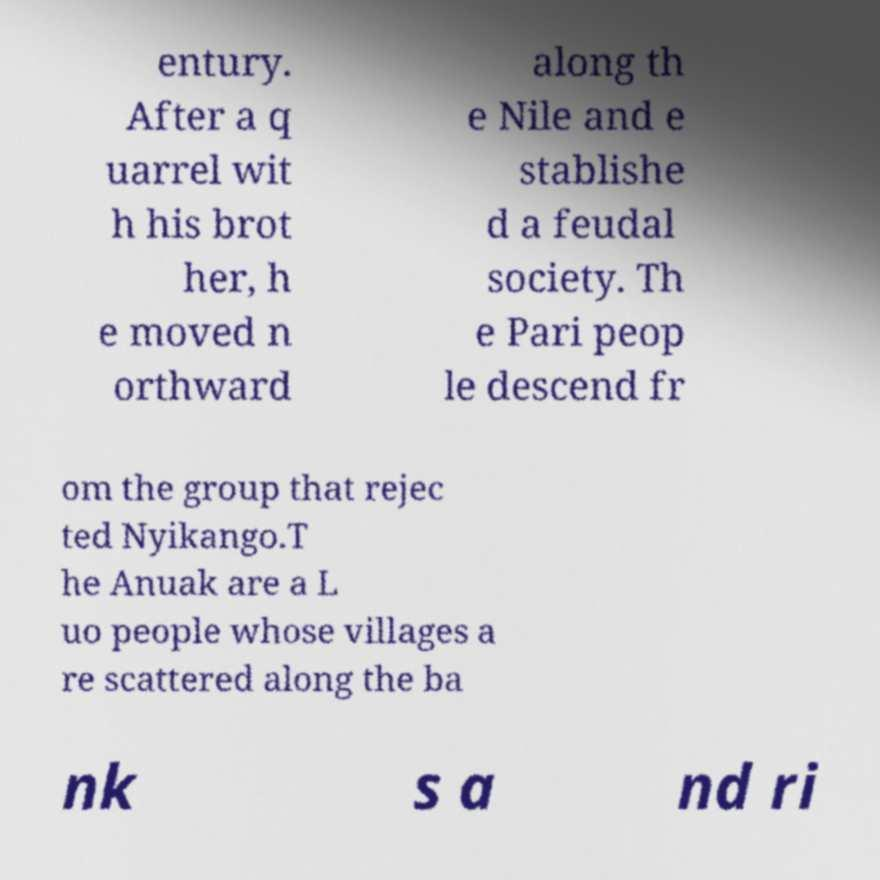For documentation purposes, I need the text within this image transcribed. Could you provide that? entury. After a q uarrel wit h his brot her, h e moved n orthward along th e Nile and e stablishe d a feudal society. Th e Pari peop le descend fr om the group that rejec ted Nyikango.T he Anuak are a L uo people whose villages a re scattered along the ba nk s a nd ri 